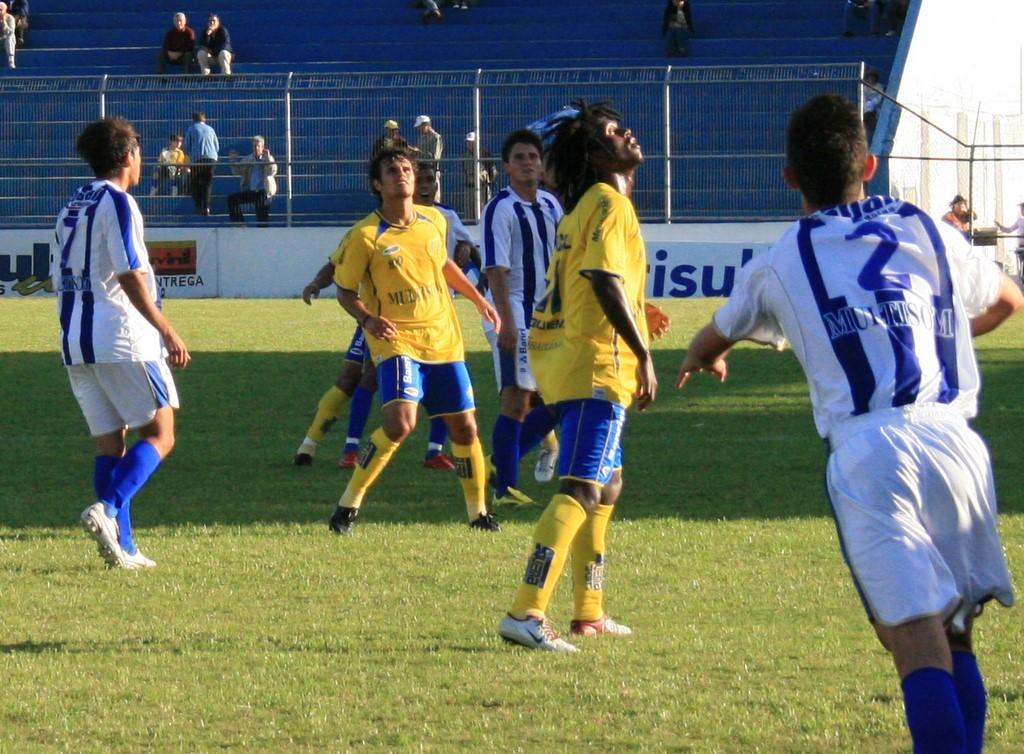What is the number on the back of the closest player's jersey?
Provide a succinct answer. 2. 